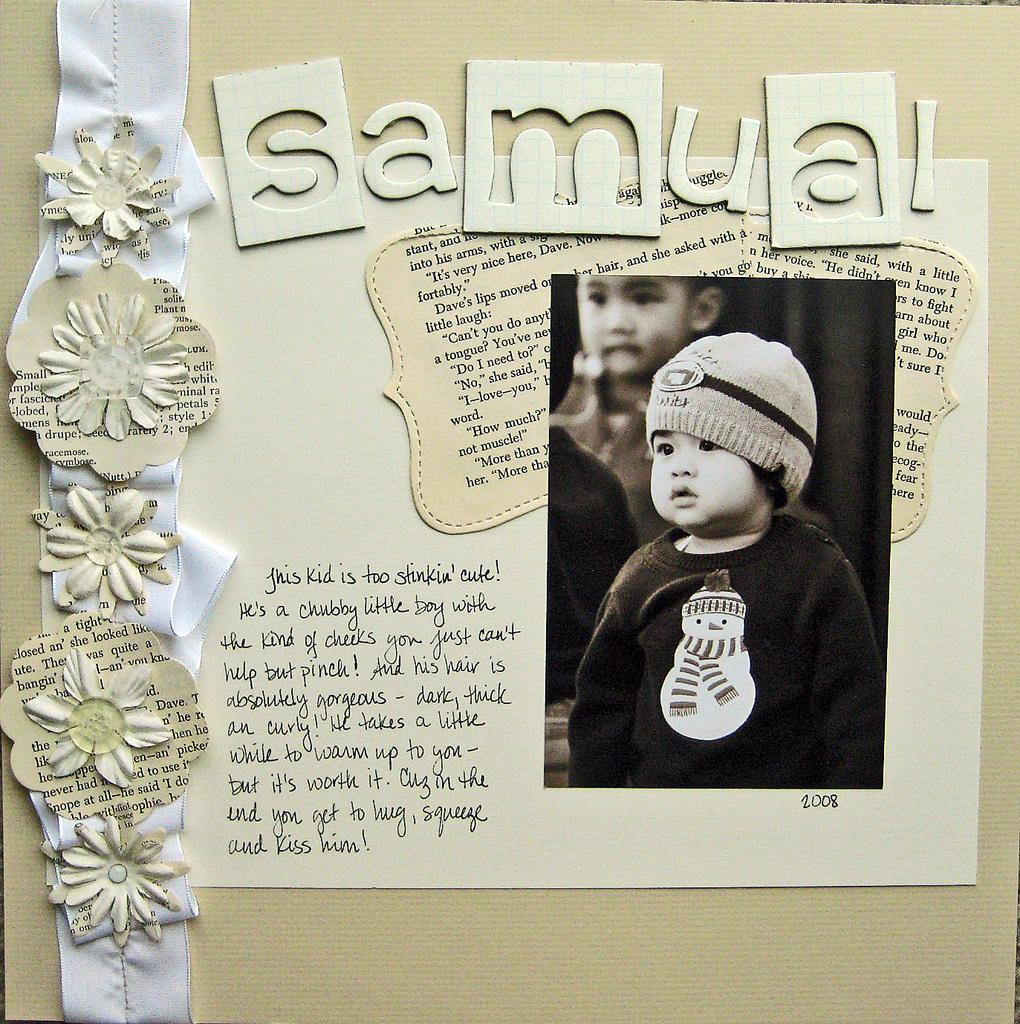What is present on the paper in the image? Something is written on the paper, and there is a baby photo on it. Can you describe the decorative items in the image? Unfortunately, the provided facts do not mention any specific decorative items. What is the purpose of the paper in the image? Based on the presence of a baby photo and writing, it seems that the paper might be a personalized item, such as a card or note. What type of base is used to support the war in the image? There is no mention of a war or any base in the image; it features a paper with writing and a baby photo. 